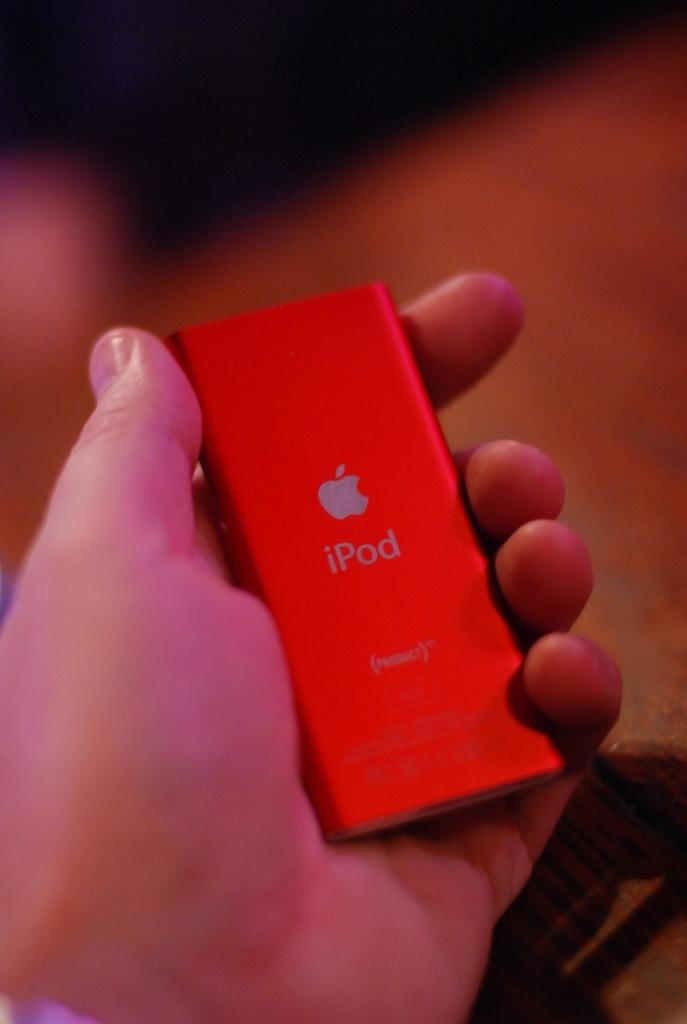<image>
Write a terse but informative summary of the picture. A hand is holding a red Apple Ipod 